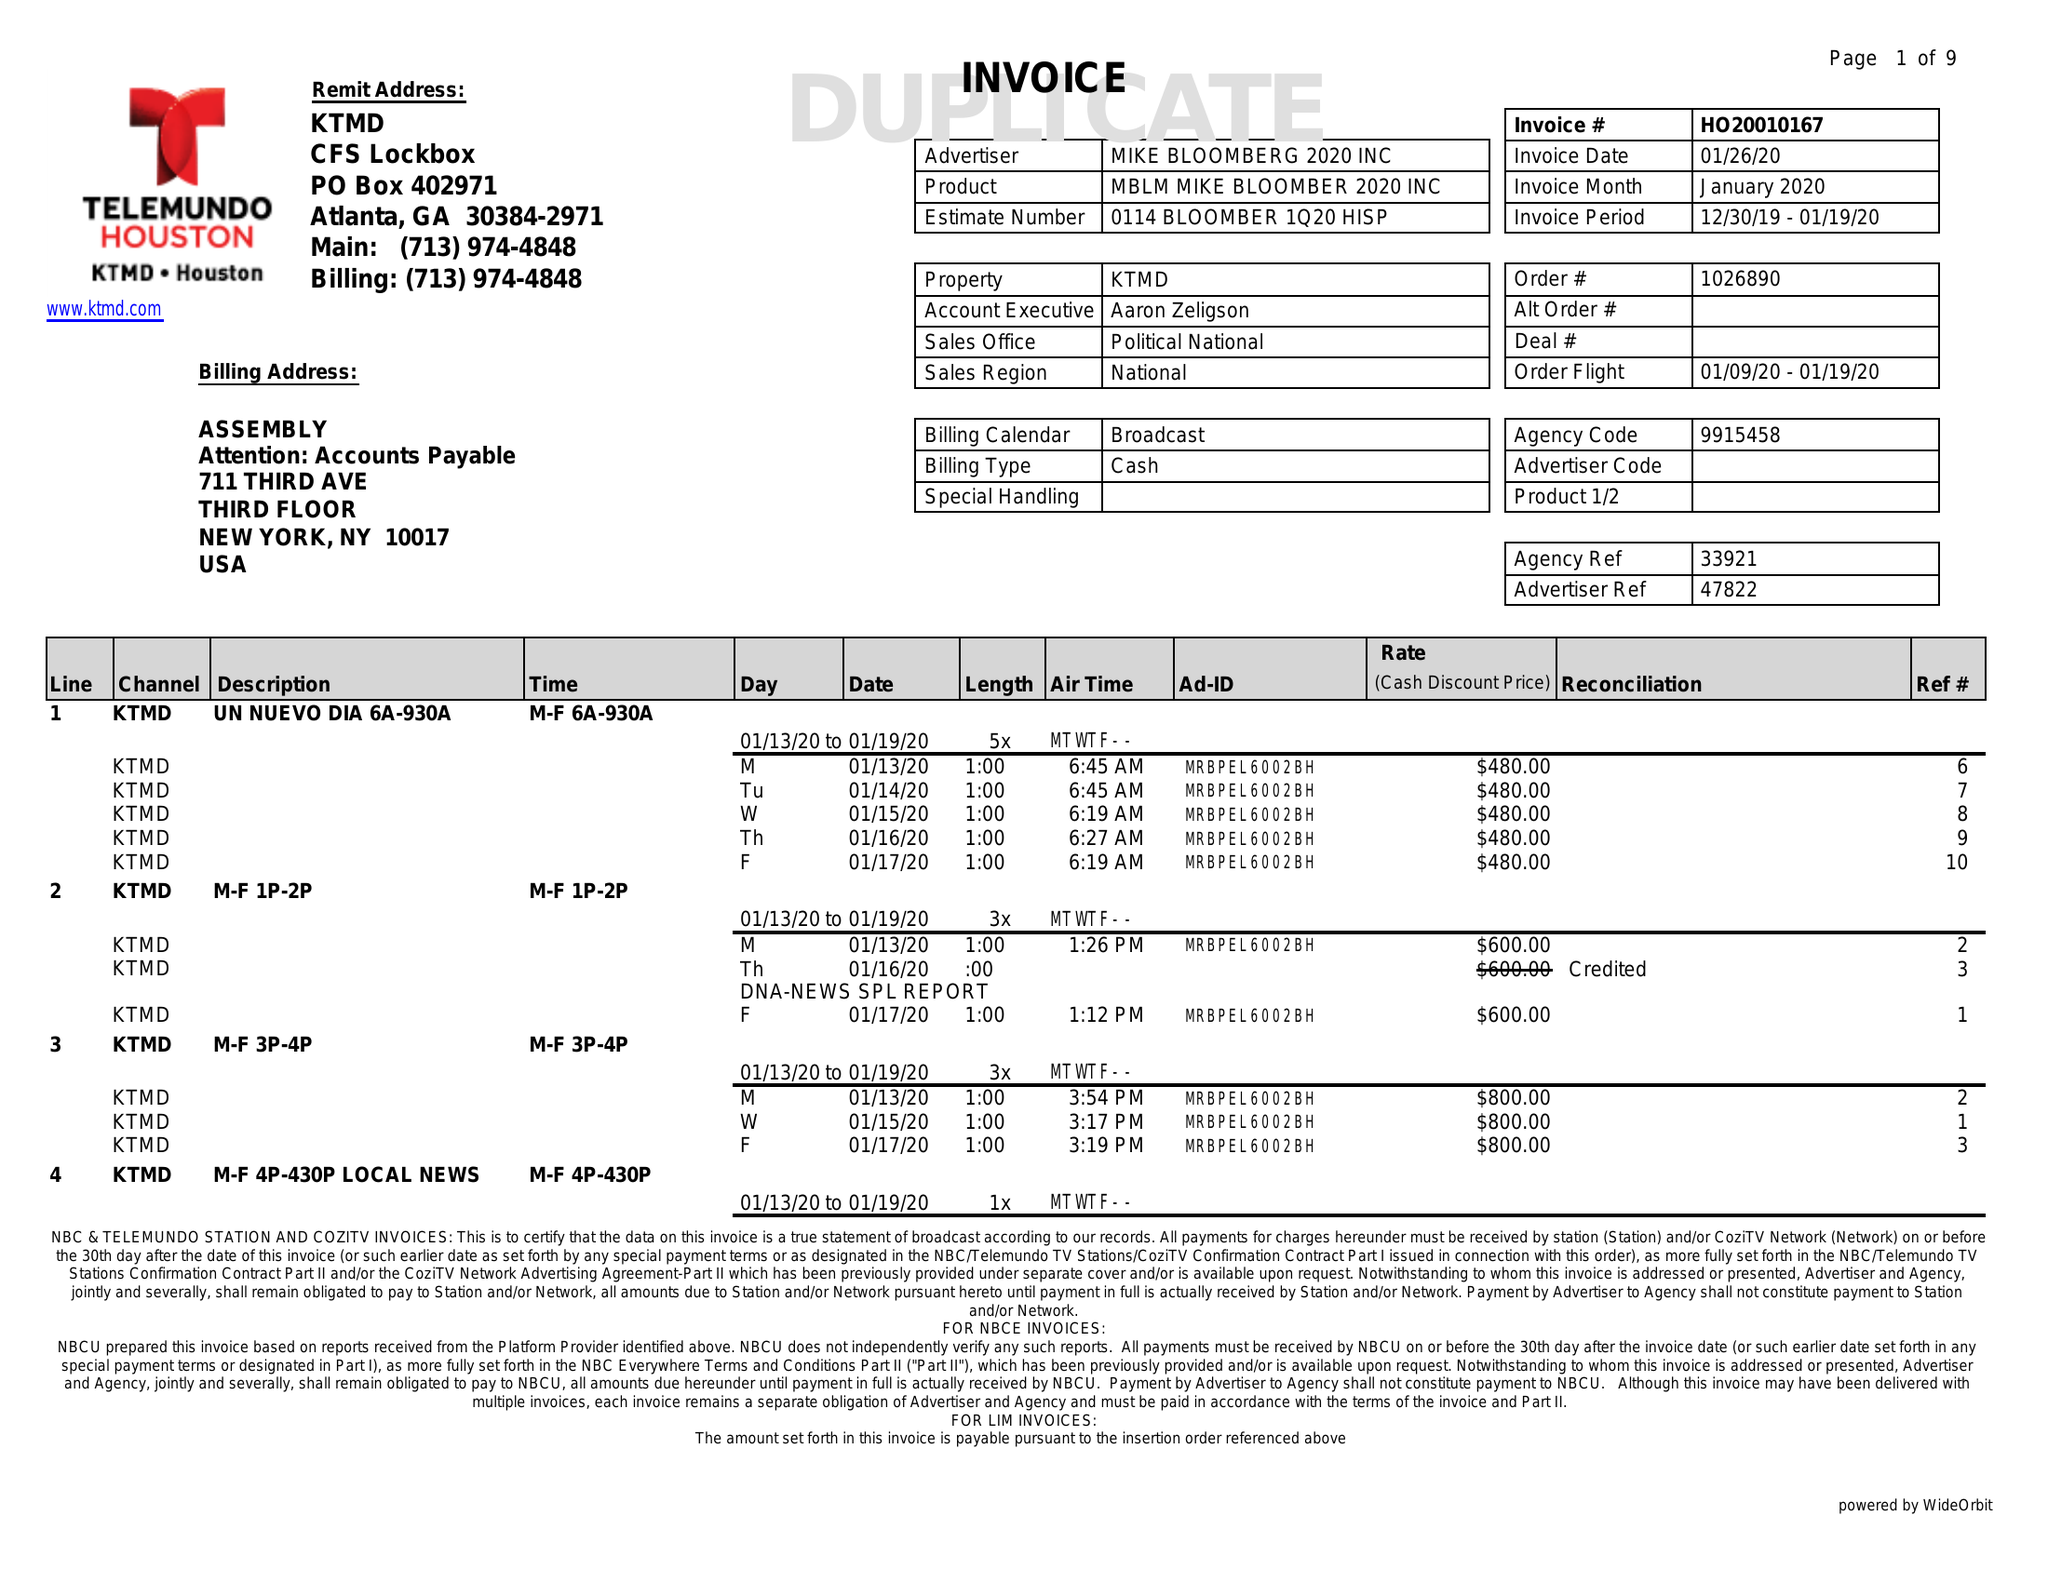What is the value for the contract_num?
Answer the question using a single word or phrase. HO20010167 